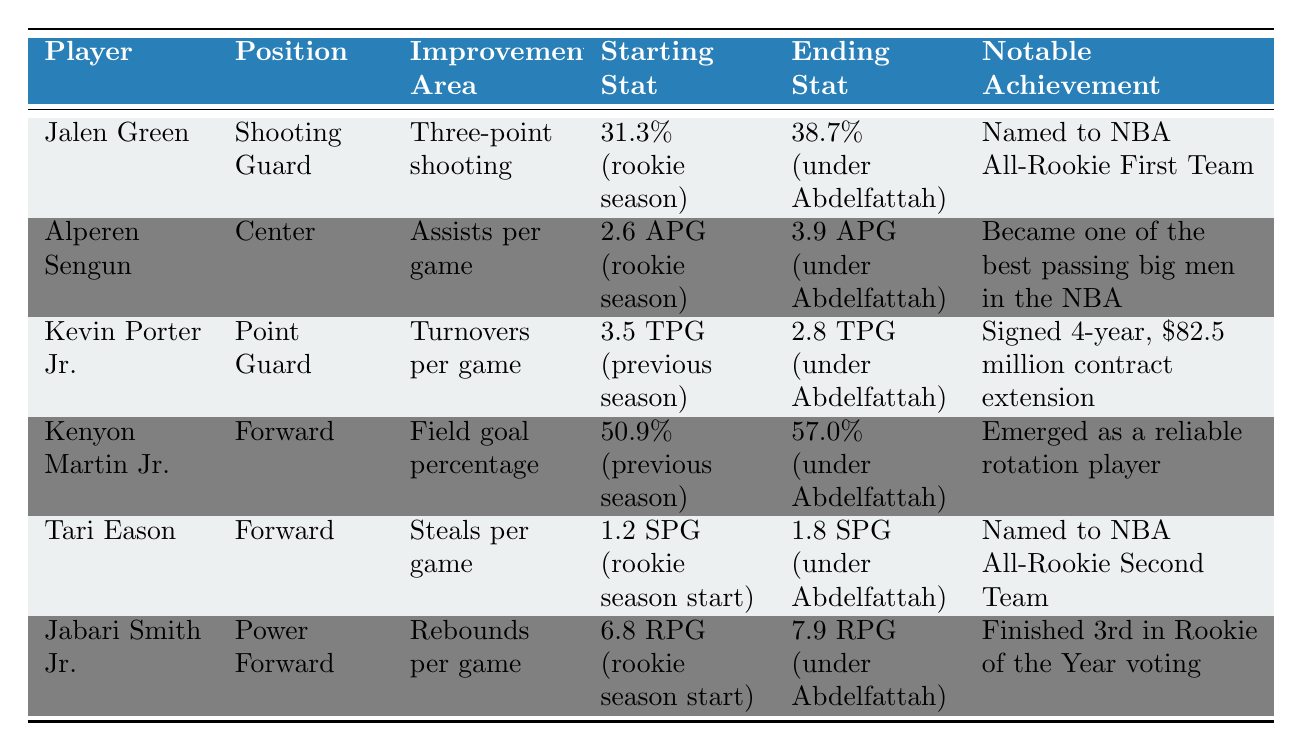What was Jalen Green's three-point shooting percentage under Mahmoud Abdelfattah? The table shows that Jalen Green's ending stat for three-point shooting under Abdelfattah was 38.7%.
Answer: 38.7% Who improved their assists per game most significantly under Abdelfattah? Alperen Sengun improved from 2.6 assists per game to 3.9 assists per game, which is a difference of 1.3. No other player has a higher improvement in assists.
Answer: Alperen Sengun Did Kevin Porter Jr. reduce his turnovers per game under Abdelfattah? According to the table, Kevin Porter Jr.'s starting turnovers per game were 3.5, and he ended with 2.8, indicating a reduction.
Answer: Yes Which player achieved the least improvement in rebounds per game? Jabari Smith Jr. improved from 6.8 to 7.9 rebounds per game, which is a difference of 1.1. Comparing this to other players, this is lower than others, indicating he had the least improvement in this area.
Answer: Jabari Smith Jr What is the average percentage increase in field goal percentage among the players listed? Kenyon Martin Jr.'s field goal percentage improved from 50.9% to 57.0%, which is a difference of 6.1%. Calculating the average significance comparing just one player does not give a simple average; thus, we have one player in this area alone.
Answer: 6.1% How many players improved their statistics in the area of scoring metrics (points related)? Jalen Green proved wider impact in three-point shooting and Kenyon Martin Jr. in field goals show improvement in scoring metrics.
Answer: 2 players Was Tari Eason recognized for his performance under Abdelfattah? The table states that Tari Eason was named to the NBA All-Rookie Second Team, which indicates recognition for his performance.
Answer: Yes Which player had the highest ending statistic in assists per game? Alperen Sengun ended with the highest assists per game at 3.9, compared to others.
Answer: Alperen Sengun What notable achievement did Kenyon Martin Jr. receive? The table indicates that Kenyon Martin Jr. emerged as a reliable rotation player, which is identified as his notable achievement.
Answer: Emerged as a reliable rotation player Which player had the most significant increase in steals per game? Tari Eason improved from 1.2 steals per game to 1.8 steals per game, making it a difference of 0.6. This is higher than any other player's improvement in steals.
Answer: Tari Eason Did any player finish higher than the 3rd in Rookie of the Year voting under Abdelfattah's coaching? The table indicates that Jabari Smith Jr. finished 3rd in Rookie of the Year voting, but doesn't show anyone finishing higher. So, no player finished higher.
Answer: No 